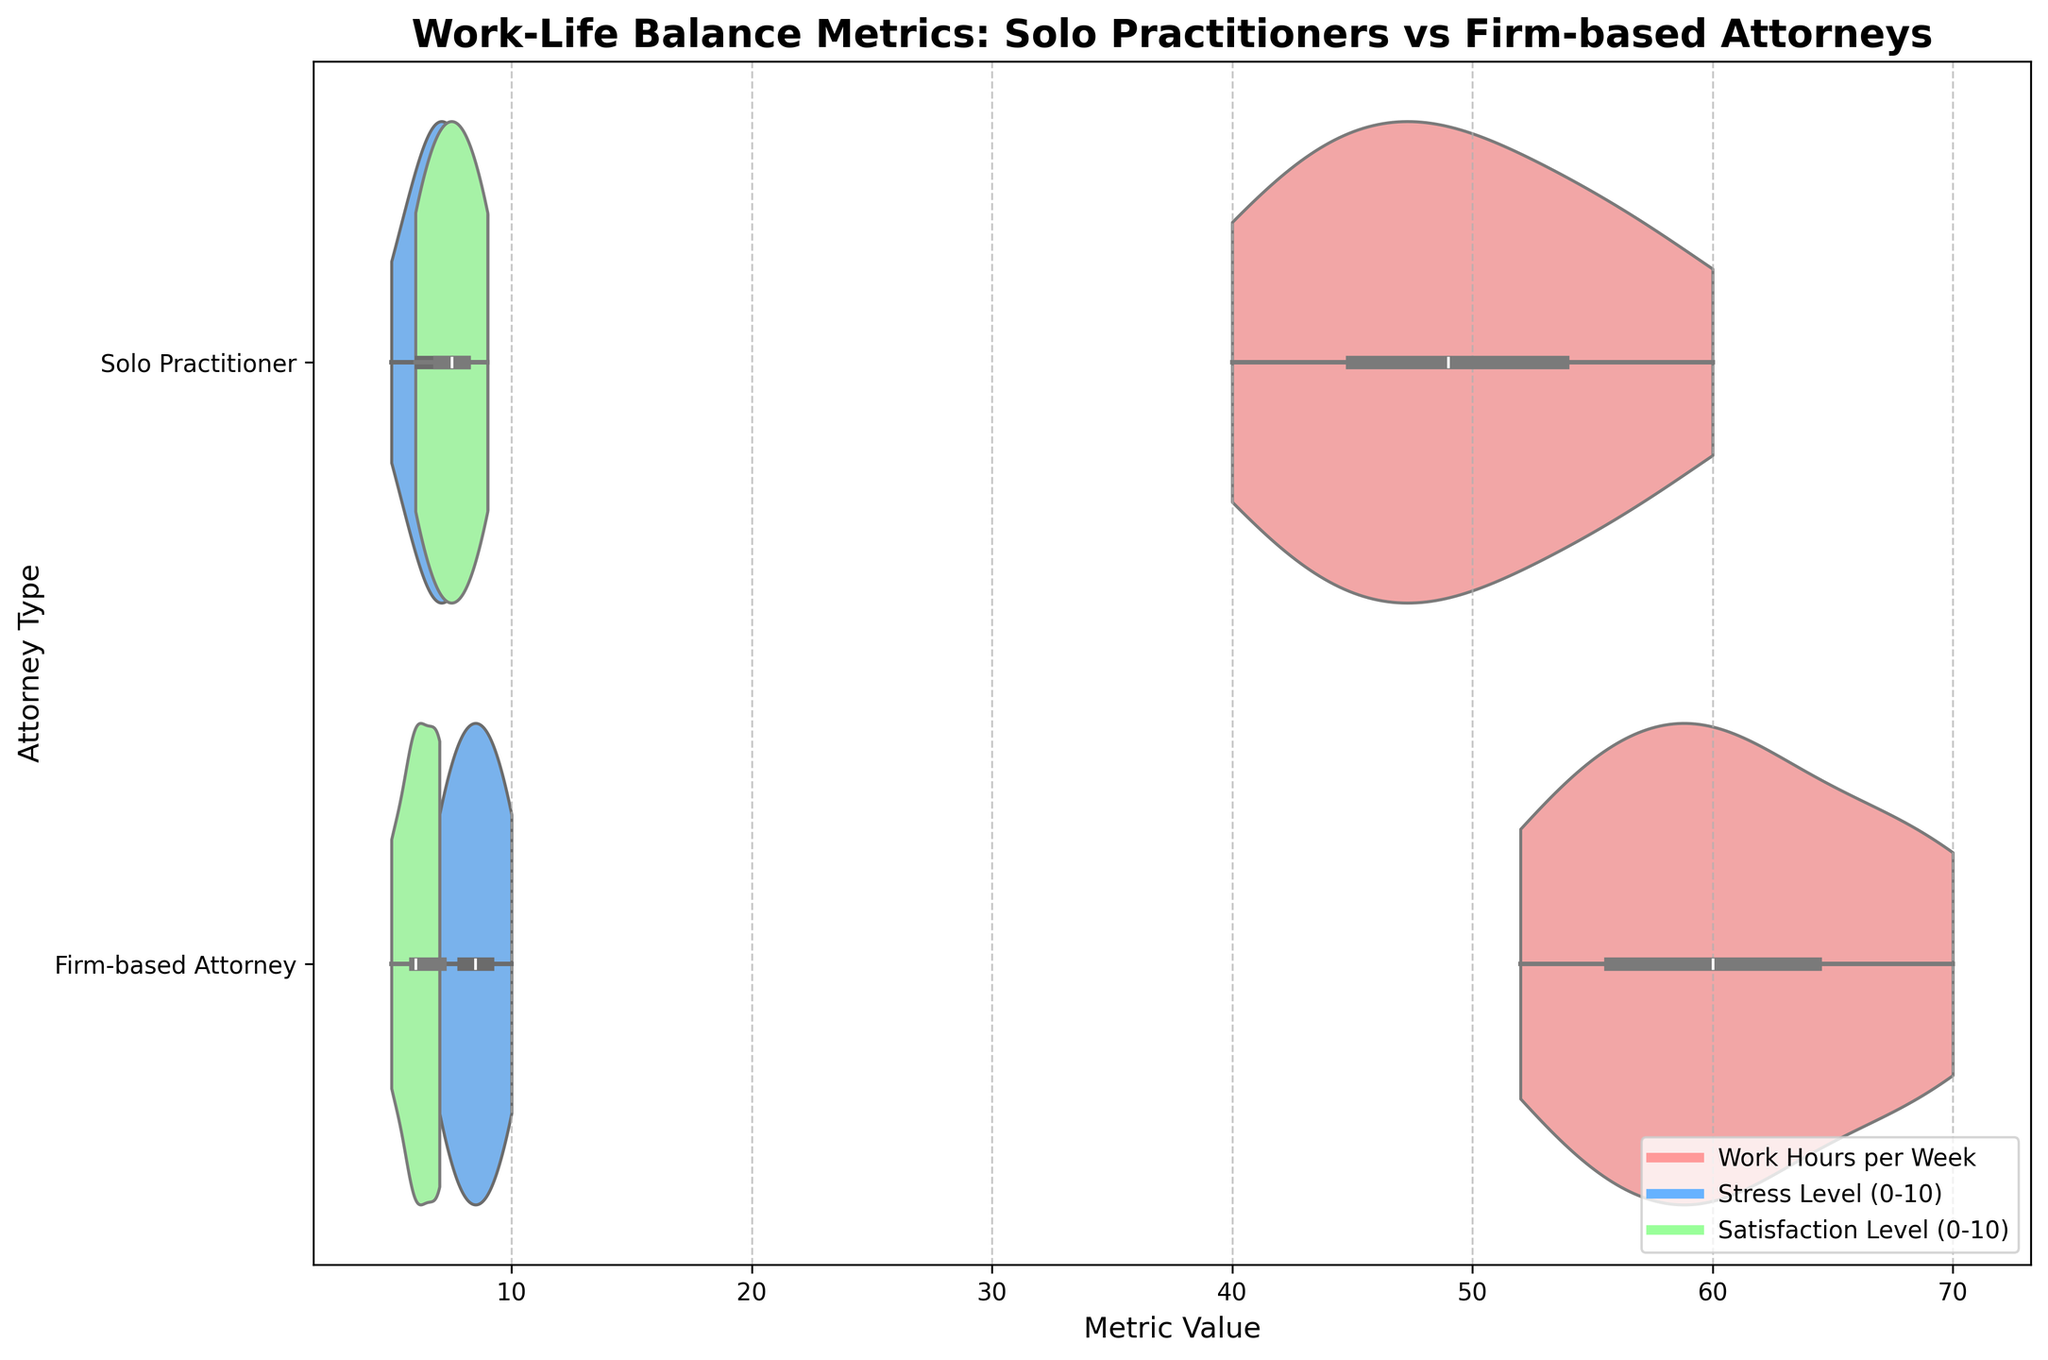What is the title of the figure? The title of the figure is usually displayed prominently at the top of the chart. In this case, it is: "Work-Life Balance Metrics: Solo Practitioners vs Firm-based Attorneys".
Answer: Work-Life Balance Metrics: Solo Practitioners vs Firm-based Attorneys Which metric uses the green color in the figure? The violin plot associated with the green color represents the "Satisfaction Level (0-10)" metric, as indicated by the color legend in the figure.
Answer: Satisfaction Level (0-10) What is the range of work hours for solo practitioners? The range can be observed by noting the minimum and maximum extents of the violin plot for solo practitioners along the "Work Hours per Week" metric. Here, it spans from 40 to 60 hours.
Answer: 40 to 60 Which type of attorney appears to have a higher stress level on average? By visually inspecting the central tendency or the bulk of the violin plots for stress levels, it is apparent that firm-based attorneys generally have a higher stress level (closer to 8 and above) compared to solo practitioners (closer to 6-7).
Answer: Firm-based attorneys What is the median satisfaction level for firm-based attorneys? The median is represented by the white marker (dot) within the box plot (embedded in the violin plot) for satisfaction levels. For firm-based attorneys, this white marker is around 6.
Answer: Around 6 Which group has the most variation in work hours? The variation is indicated by the width of the violin plot. Firm-based attorneys have a wider distribution in the work hours plot compared to solo practitioners, suggesting more variation.
Answer: Firm-based attorneys Is there overlap in work hours between solo practitioners and firm-based attorneys? By comparing the work hours violin plots for both groups, one can see that there is an overlapping range between approximately 50-60 hours per week.
Answer: Yes How do the average stress levels differ between the two types of attorneys? Averaging the central values where most of the data is concentrated in the violin plots, solo practitioners average around 6-8 in stress levels, while firm-based attorneys average around 8-9, indicating higher stress in firm-based attorneys.
Answer: Firm-based attorneys have higher average stress levels What does the inner box in the violin plot represent? The inner box within the violin plot shows the interquartile range (IQR) and the median as the white dot, which provides a clear visual of the central tendency and spread of the data.
Answer: Interquartile range and median Which metric shows the least amount of difference between the two groups? By comparing the overlap and distribution of all metrics, "Satisfaction Level (0-10)" shows considerable overlap and similarity between both groups, indicating the least difference.
Answer: Satisfaction Level (0-10) 